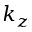<formula> <loc_0><loc_0><loc_500><loc_500>k _ { z }</formula> 